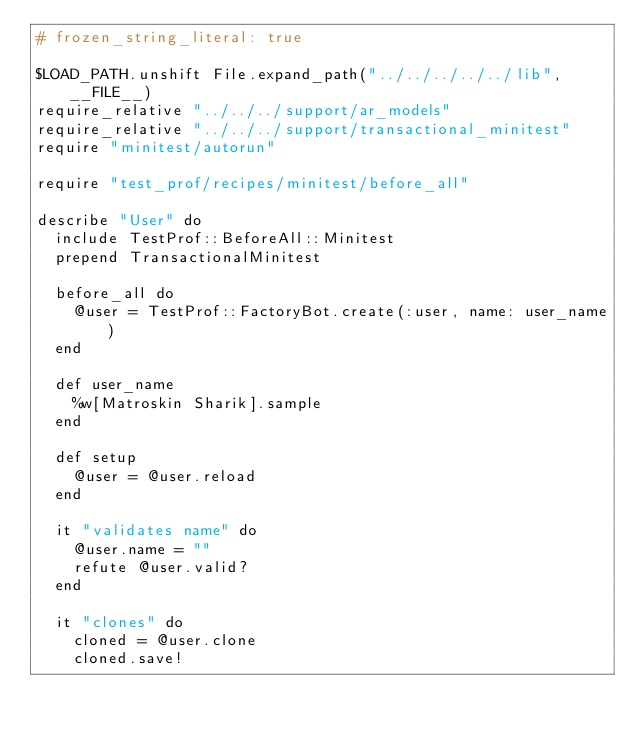Convert code to text. <code><loc_0><loc_0><loc_500><loc_500><_Ruby_># frozen_string_literal: true

$LOAD_PATH.unshift File.expand_path("../../../../../lib", __FILE__)
require_relative "../../../support/ar_models"
require_relative "../../../support/transactional_minitest"
require "minitest/autorun"

require "test_prof/recipes/minitest/before_all"

describe "User" do
  include TestProf::BeforeAll::Minitest
  prepend TransactionalMinitest

  before_all do
    @user = TestProf::FactoryBot.create(:user, name: user_name)
  end

  def user_name
    %w[Matroskin Sharik].sample
  end

  def setup
    @user = @user.reload
  end

  it "validates name" do
    @user.name = ""
    refute @user.valid?
  end

  it "clones" do
    cloned = @user.clone
    cloned.save!</code> 